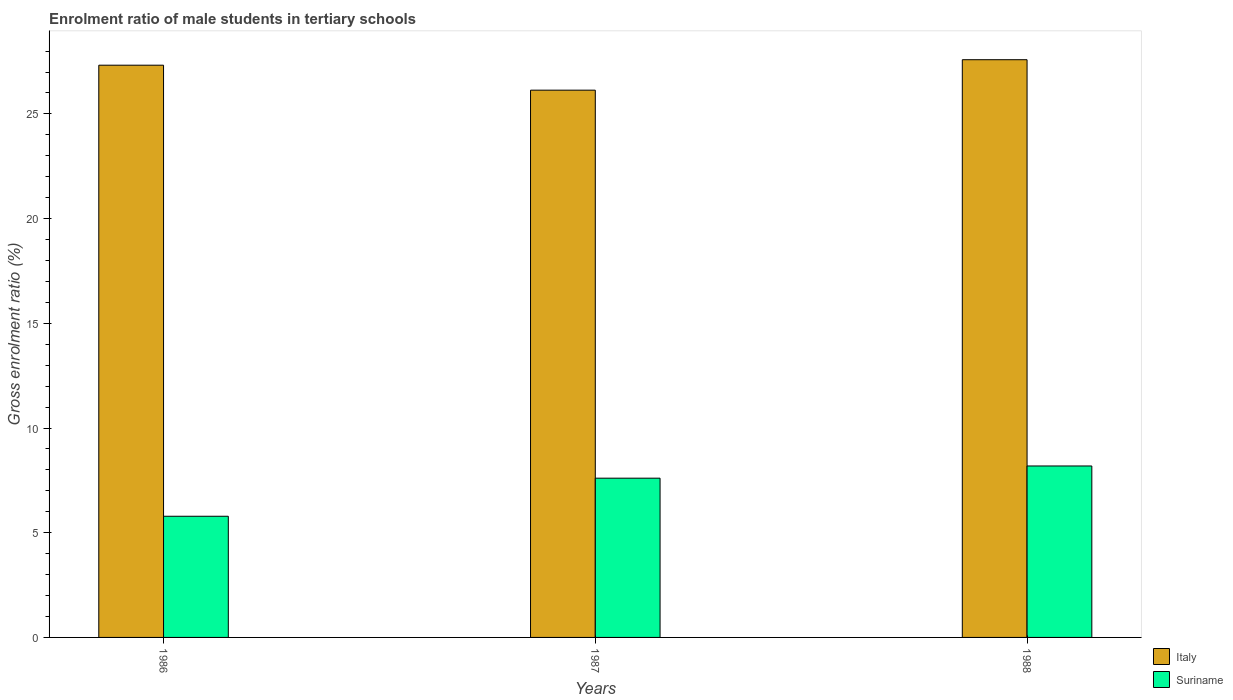Are the number of bars per tick equal to the number of legend labels?
Keep it short and to the point. Yes. Are the number of bars on each tick of the X-axis equal?
Your answer should be very brief. Yes. How many bars are there on the 3rd tick from the left?
Give a very brief answer. 2. In how many cases, is the number of bars for a given year not equal to the number of legend labels?
Make the answer very short. 0. What is the enrolment ratio of male students in tertiary schools in Suriname in 1988?
Your answer should be very brief. 8.19. Across all years, what is the maximum enrolment ratio of male students in tertiary schools in Italy?
Keep it short and to the point. 27.59. Across all years, what is the minimum enrolment ratio of male students in tertiary schools in Italy?
Keep it short and to the point. 26.13. In which year was the enrolment ratio of male students in tertiary schools in Italy minimum?
Your answer should be compact. 1987. What is the total enrolment ratio of male students in tertiary schools in Suriname in the graph?
Provide a succinct answer. 21.58. What is the difference between the enrolment ratio of male students in tertiary schools in Suriname in 1986 and that in 1988?
Offer a terse response. -2.4. What is the difference between the enrolment ratio of male students in tertiary schools in Suriname in 1988 and the enrolment ratio of male students in tertiary schools in Italy in 1987?
Provide a succinct answer. -17.95. What is the average enrolment ratio of male students in tertiary schools in Suriname per year?
Keep it short and to the point. 7.19. In the year 1986, what is the difference between the enrolment ratio of male students in tertiary schools in Suriname and enrolment ratio of male students in tertiary schools in Italy?
Ensure brevity in your answer.  -21.54. What is the ratio of the enrolment ratio of male students in tertiary schools in Suriname in 1986 to that in 1987?
Keep it short and to the point. 0.76. Is the enrolment ratio of male students in tertiary schools in Suriname in 1986 less than that in 1987?
Offer a terse response. Yes. What is the difference between the highest and the second highest enrolment ratio of male students in tertiary schools in Italy?
Your answer should be compact. 0.26. What is the difference between the highest and the lowest enrolment ratio of male students in tertiary schools in Suriname?
Ensure brevity in your answer.  2.4. Is the sum of the enrolment ratio of male students in tertiary schools in Italy in 1987 and 1988 greater than the maximum enrolment ratio of male students in tertiary schools in Suriname across all years?
Keep it short and to the point. Yes. What does the 1st bar from the left in 1987 represents?
Provide a succinct answer. Italy. What does the 1st bar from the right in 1987 represents?
Your response must be concise. Suriname. How many bars are there?
Ensure brevity in your answer.  6. Are all the bars in the graph horizontal?
Your answer should be very brief. No. Does the graph contain any zero values?
Provide a short and direct response. No. How many legend labels are there?
Offer a terse response. 2. How are the legend labels stacked?
Keep it short and to the point. Vertical. What is the title of the graph?
Offer a terse response. Enrolment ratio of male students in tertiary schools. Does "Cambodia" appear as one of the legend labels in the graph?
Make the answer very short. No. What is the label or title of the Y-axis?
Give a very brief answer. Gross enrolment ratio (%). What is the Gross enrolment ratio (%) in Italy in 1986?
Your response must be concise. 27.33. What is the Gross enrolment ratio (%) of Suriname in 1986?
Your response must be concise. 5.79. What is the Gross enrolment ratio (%) in Italy in 1987?
Provide a succinct answer. 26.13. What is the Gross enrolment ratio (%) in Suriname in 1987?
Your answer should be very brief. 7.6. What is the Gross enrolment ratio (%) of Italy in 1988?
Keep it short and to the point. 27.59. What is the Gross enrolment ratio (%) of Suriname in 1988?
Offer a very short reply. 8.19. Across all years, what is the maximum Gross enrolment ratio (%) in Italy?
Give a very brief answer. 27.59. Across all years, what is the maximum Gross enrolment ratio (%) of Suriname?
Provide a short and direct response. 8.19. Across all years, what is the minimum Gross enrolment ratio (%) of Italy?
Make the answer very short. 26.13. Across all years, what is the minimum Gross enrolment ratio (%) in Suriname?
Offer a terse response. 5.79. What is the total Gross enrolment ratio (%) in Italy in the graph?
Your answer should be very brief. 81.05. What is the total Gross enrolment ratio (%) in Suriname in the graph?
Give a very brief answer. 21.58. What is the difference between the Gross enrolment ratio (%) of Italy in 1986 and that in 1987?
Keep it short and to the point. 1.19. What is the difference between the Gross enrolment ratio (%) in Suriname in 1986 and that in 1987?
Your response must be concise. -1.82. What is the difference between the Gross enrolment ratio (%) in Italy in 1986 and that in 1988?
Your answer should be very brief. -0.26. What is the difference between the Gross enrolment ratio (%) of Suriname in 1986 and that in 1988?
Keep it short and to the point. -2.4. What is the difference between the Gross enrolment ratio (%) of Italy in 1987 and that in 1988?
Provide a succinct answer. -1.45. What is the difference between the Gross enrolment ratio (%) of Suriname in 1987 and that in 1988?
Your answer should be very brief. -0.58. What is the difference between the Gross enrolment ratio (%) of Italy in 1986 and the Gross enrolment ratio (%) of Suriname in 1987?
Your answer should be compact. 19.72. What is the difference between the Gross enrolment ratio (%) of Italy in 1986 and the Gross enrolment ratio (%) of Suriname in 1988?
Give a very brief answer. 19.14. What is the difference between the Gross enrolment ratio (%) in Italy in 1987 and the Gross enrolment ratio (%) in Suriname in 1988?
Offer a terse response. 17.95. What is the average Gross enrolment ratio (%) in Italy per year?
Your answer should be very brief. 27.02. What is the average Gross enrolment ratio (%) in Suriname per year?
Offer a very short reply. 7.19. In the year 1986, what is the difference between the Gross enrolment ratio (%) in Italy and Gross enrolment ratio (%) in Suriname?
Your answer should be very brief. 21.54. In the year 1987, what is the difference between the Gross enrolment ratio (%) in Italy and Gross enrolment ratio (%) in Suriname?
Offer a terse response. 18.53. In the year 1988, what is the difference between the Gross enrolment ratio (%) in Italy and Gross enrolment ratio (%) in Suriname?
Ensure brevity in your answer.  19.4. What is the ratio of the Gross enrolment ratio (%) of Italy in 1986 to that in 1987?
Make the answer very short. 1.05. What is the ratio of the Gross enrolment ratio (%) of Suriname in 1986 to that in 1987?
Ensure brevity in your answer.  0.76. What is the ratio of the Gross enrolment ratio (%) of Italy in 1986 to that in 1988?
Provide a succinct answer. 0.99. What is the ratio of the Gross enrolment ratio (%) of Suriname in 1986 to that in 1988?
Provide a short and direct response. 0.71. What is the ratio of the Gross enrolment ratio (%) in Italy in 1987 to that in 1988?
Provide a short and direct response. 0.95. What is the ratio of the Gross enrolment ratio (%) of Suriname in 1987 to that in 1988?
Provide a short and direct response. 0.93. What is the difference between the highest and the second highest Gross enrolment ratio (%) in Italy?
Your response must be concise. 0.26. What is the difference between the highest and the second highest Gross enrolment ratio (%) in Suriname?
Your answer should be very brief. 0.58. What is the difference between the highest and the lowest Gross enrolment ratio (%) of Italy?
Provide a succinct answer. 1.45. What is the difference between the highest and the lowest Gross enrolment ratio (%) of Suriname?
Offer a very short reply. 2.4. 